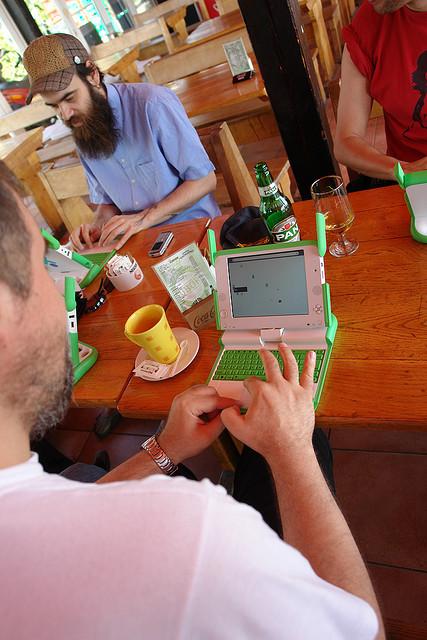What is the table made out of?
Short answer required. Wood. Is this laptop suitable for a man?
Be succinct. No. What is on the man's head with the blue shirt?
Answer briefly. Hat. Is this man chewing a hot dog?
Answer briefly. No. What beverage are they drinking?
Be succinct. Beer. 